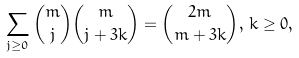<formula> <loc_0><loc_0><loc_500><loc_500>\sum _ { j \geq 0 } \binom { m } { j } \binom { m } { j + 3 k } = \binom { 2 m } { m + 3 k } , \, k \geq 0 ,</formula> 